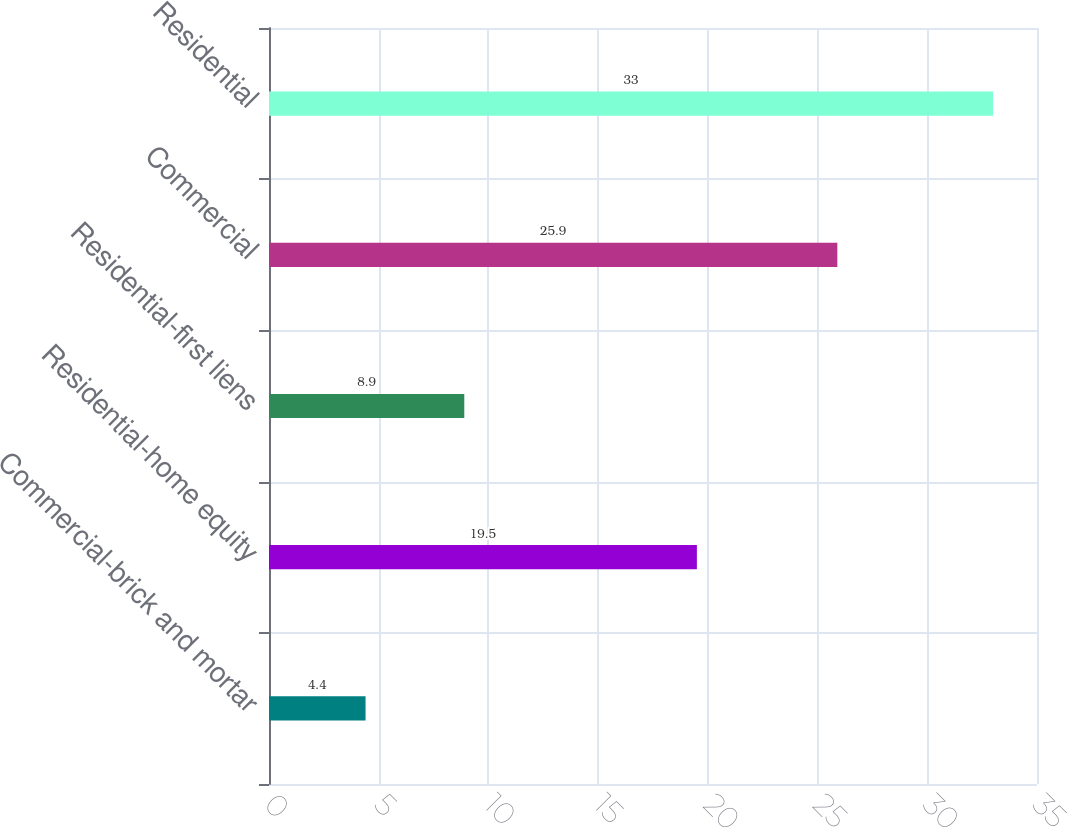<chart> <loc_0><loc_0><loc_500><loc_500><bar_chart><fcel>Commercial-brick and mortar<fcel>Residential-home equity<fcel>Residential-first liens<fcel>Commercial<fcel>Residential<nl><fcel>4.4<fcel>19.5<fcel>8.9<fcel>25.9<fcel>33<nl></chart> 